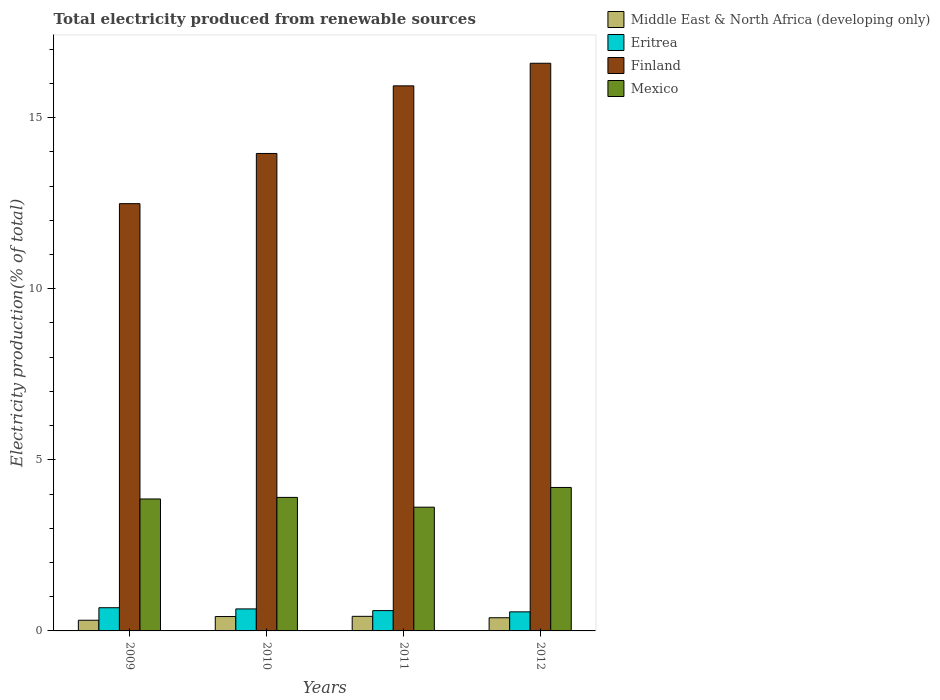Are the number of bars on each tick of the X-axis equal?
Make the answer very short. Yes. What is the total electricity produced in Eritrea in 2009?
Make the answer very short. 0.68. Across all years, what is the maximum total electricity produced in Eritrea?
Offer a very short reply. 0.68. Across all years, what is the minimum total electricity produced in Middle East & North Africa (developing only)?
Offer a terse response. 0.31. In which year was the total electricity produced in Middle East & North Africa (developing only) maximum?
Your answer should be very brief. 2011. In which year was the total electricity produced in Finland minimum?
Ensure brevity in your answer.  2009. What is the total total electricity produced in Eritrea in the graph?
Provide a short and direct response. 2.47. What is the difference between the total electricity produced in Middle East & North Africa (developing only) in 2011 and that in 2012?
Your response must be concise. 0.04. What is the difference between the total electricity produced in Eritrea in 2011 and the total electricity produced in Finland in 2009?
Make the answer very short. -11.89. What is the average total electricity produced in Mexico per year?
Your answer should be compact. 3.89. In the year 2009, what is the difference between the total electricity produced in Eritrea and total electricity produced in Middle East & North Africa (developing only)?
Make the answer very short. 0.37. What is the ratio of the total electricity produced in Mexico in 2011 to that in 2012?
Ensure brevity in your answer.  0.86. What is the difference between the highest and the second highest total electricity produced in Eritrea?
Offer a very short reply. 0.03. What is the difference between the highest and the lowest total electricity produced in Mexico?
Keep it short and to the point. 0.58. In how many years, is the total electricity produced in Eritrea greater than the average total electricity produced in Eritrea taken over all years?
Provide a succinct answer. 2. Is the sum of the total electricity produced in Middle East & North Africa (developing only) in 2010 and 2012 greater than the maximum total electricity produced in Eritrea across all years?
Give a very brief answer. Yes. What does the 1st bar from the left in 2012 represents?
Your answer should be compact. Middle East & North Africa (developing only). Is it the case that in every year, the sum of the total electricity produced in Finland and total electricity produced in Eritrea is greater than the total electricity produced in Mexico?
Make the answer very short. Yes. How many bars are there?
Offer a very short reply. 16. What is the difference between two consecutive major ticks on the Y-axis?
Give a very brief answer. 5. Does the graph contain grids?
Your answer should be very brief. No. Where does the legend appear in the graph?
Ensure brevity in your answer.  Top right. How many legend labels are there?
Give a very brief answer. 4. What is the title of the graph?
Your response must be concise. Total electricity produced from renewable sources. Does "Guinea" appear as one of the legend labels in the graph?
Offer a terse response. No. What is the label or title of the X-axis?
Offer a very short reply. Years. What is the label or title of the Y-axis?
Ensure brevity in your answer.  Electricity production(% of total). What is the Electricity production(% of total) of Middle East & North Africa (developing only) in 2009?
Keep it short and to the point. 0.31. What is the Electricity production(% of total) of Eritrea in 2009?
Give a very brief answer. 0.68. What is the Electricity production(% of total) of Finland in 2009?
Your answer should be compact. 12.49. What is the Electricity production(% of total) in Mexico in 2009?
Your answer should be very brief. 3.86. What is the Electricity production(% of total) of Middle East & North Africa (developing only) in 2010?
Offer a terse response. 0.42. What is the Electricity production(% of total) of Eritrea in 2010?
Keep it short and to the point. 0.64. What is the Electricity production(% of total) of Finland in 2010?
Your response must be concise. 13.95. What is the Electricity production(% of total) of Mexico in 2010?
Provide a succinct answer. 3.9. What is the Electricity production(% of total) of Middle East & North Africa (developing only) in 2011?
Offer a terse response. 0.43. What is the Electricity production(% of total) in Eritrea in 2011?
Give a very brief answer. 0.59. What is the Electricity production(% of total) in Finland in 2011?
Provide a short and direct response. 15.93. What is the Electricity production(% of total) of Mexico in 2011?
Your answer should be compact. 3.62. What is the Electricity production(% of total) of Middle East & North Africa (developing only) in 2012?
Offer a very short reply. 0.38. What is the Electricity production(% of total) of Eritrea in 2012?
Make the answer very short. 0.56. What is the Electricity production(% of total) in Finland in 2012?
Your answer should be very brief. 16.59. What is the Electricity production(% of total) in Mexico in 2012?
Provide a short and direct response. 4.19. Across all years, what is the maximum Electricity production(% of total) in Middle East & North Africa (developing only)?
Offer a terse response. 0.43. Across all years, what is the maximum Electricity production(% of total) in Eritrea?
Give a very brief answer. 0.68. Across all years, what is the maximum Electricity production(% of total) of Finland?
Offer a terse response. 16.59. Across all years, what is the maximum Electricity production(% of total) in Mexico?
Offer a terse response. 4.19. Across all years, what is the minimum Electricity production(% of total) of Middle East & North Africa (developing only)?
Your response must be concise. 0.31. Across all years, what is the minimum Electricity production(% of total) in Eritrea?
Offer a terse response. 0.56. Across all years, what is the minimum Electricity production(% of total) of Finland?
Your answer should be very brief. 12.49. Across all years, what is the minimum Electricity production(% of total) of Mexico?
Provide a short and direct response. 3.62. What is the total Electricity production(% of total) in Middle East & North Africa (developing only) in the graph?
Give a very brief answer. 1.54. What is the total Electricity production(% of total) of Eritrea in the graph?
Your response must be concise. 2.47. What is the total Electricity production(% of total) in Finland in the graph?
Offer a terse response. 58.96. What is the total Electricity production(% of total) of Mexico in the graph?
Ensure brevity in your answer.  15.57. What is the difference between the Electricity production(% of total) of Middle East & North Africa (developing only) in 2009 and that in 2010?
Offer a very short reply. -0.11. What is the difference between the Electricity production(% of total) of Eritrea in 2009 and that in 2010?
Make the answer very short. 0.03. What is the difference between the Electricity production(% of total) of Finland in 2009 and that in 2010?
Your answer should be very brief. -1.47. What is the difference between the Electricity production(% of total) of Mexico in 2009 and that in 2010?
Offer a very short reply. -0.05. What is the difference between the Electricity production(% of total) in Middle East & North Africa (developing only) in 2009 and that in 2011?
Ensure brevity in your answer.  -0.11. What is the difference between the Electricity production(% of total) in Eritrea in 2009 and that in 2011?
Provide a succinct answer. 0.08. What is the difference between the Electricity production(% of total) in Finland in 2009 and that in 2011?
Make the answer very short. -3.44. What is the difference between the Electricity production(% of total) in Mexico in 2009 and that in 2011?
Offer a very short reply. 0.24. What is the difference between the Electricity production(% of total) of Middle East & North Africa (developing only) in 2009 and that in 2012?
Ensure brevity in your answer.  -0.07. What is the difference between the Electricity production(% of total) in Eritrea in 2009 and that in 2012?
Provide a succinct answer. 0.12. What is the difference between the Electricity production(% of total) of Finland in 2009 and that in 2012?
Your answer should be compact. -4.1. What is the difference between the Electricity production(% of total) of Mexico in 2009 and that in 2012?
Provide a succinct answer. -0.34. What is the difference between the Electricity production(% of total) of Middle East & North Africa (developing only) in 2010 and that in 2011?
Offer a very short reply. -0.01. What is the difference between the Electricity production(% of total) in Eritrea in 2010 and that in 2011?
Provide a succinct answer. 0.05. What is the difference between the Electricity production(% of total) of Finland in 2010 and that in 2011?
Give a very brief answer. -1.98. What is the difference between the Electricity production(% of total) of Mexico in 2010 and that in 2011?
Your response must be concise. 0.29. What is the difference between the Electricity production(% of total) in Middle East & North Africa (developing only) in 2010 and that in 2012?
Make the answer very short. 0.04. What is the difference between the Electricity production(% of total) of Eritrea in 2010 and that in 2012?
Keep it short and to the point. 0.09. What is the difference between the Electricity production(% of total) of Finland in 2010 and that in 2012?
Ensure brevity in your answer.  -2.64. What is the difference between the Electricity production(% of total) in Mexico in 2010 and that in 2012?
Provide a succinct answer. -0.29. What is the difference between the Electricity production(% of total) of Middle East & North Africa (developing only) in 2011 and that in 2012?
Your response must be concise. 0.04. What is the difference between the Electricity production(% of total) of Eritrea in 2011 and that in 2012?
Provide a short and direct response. 0.04. What is the difference between the Electricity production(% of total) in Finland in 2011 and that in 2012?
Keep it short and to the point. -0.66. What is the difference between the Electricity production(% of total) in Mexico in 2011 and that in 2012?
Ensure brevity in your answer.  -0.58. What is the difference between the Electricity production(% of total) of Middle East & North Africa (developing only) in 2009 and the Electricity production(% of total) of Eritrea in 2010?
Provide a succinct answer. -0.33. What is the difference between the Electricity production(% of total) of Middle East & North Africa (developing only) in 2009 and the Electricity production(% of total) of Finland in 2010?
Give a very brief answer. -13.64. What is the difference between the Electricity production(% of total) in Middle East & North Africa (developing only) in 2009 and the Electricity production(% of total) in Mexico in 2010?
Provide a short and direct response. -3.59. What is the difference between the Electricity production(% of total) of Eritrea in 2009 and the Electricity production(% of total) of Finland in 2010?
Make the answer very short. -13.28. What is the difference between the Electricity production(% of total) in Eritrea in 2009 and the Electricity production(% of total) in Mexico in 2010?
Make the answer very short. -3.22. What is the difference between the Electricity production(% of total) in Finland in 2009 and the Electricity production(% of total) in Mexico in 2010?
Keep it short and to the point. 8.58. What is the difference between the Electricity production(% of total) of Middle East & North Africa (developing only) in 2009 and the Electricity production(% of total) of Eritrea in 2011?
Offer a terse response. -0.28. What is the difference between the Electricity production(% of total) of Middle East & North Africa (developing only) in 2009 and the Electricity production(% of total) of Finland in 2011?
Your response must be concise. -15.62. What is the difference between the Electricity production(% of total) of Middle East & North Africa (developing only) in 2009 and the Electricity production(% of total) of Mexico in 2011?
Your response must be concise. -3.3. What is the difference between the Electricity production(% of total) in Eritrea in 2009 and the Electricity production(% of total) in Finland in 2011?
Make the answer very short. -15.25. What is the difference between the Electricity production(% of total) of Eritrea in 2009 and the Electricity production(% of total) of Mexico in 2011?
Give a very brief answer. -2.94. What is the difference between the Electricity production(% of total) of Finland in 2009 and the Electricity production(% of total) of Mexico in 2011?
Offer a very short reply. 8.87. What is the difference between the Electricity production(% of total) of Middle East & North Africa (developing only) in 2009 and the Electricity production(% of total) of Eritrea in 2012?
Make the answer very short. -0.24. What is the difference between the Electricity production(% of total) of Middle East & North Africa (developing only) in 2009 and the Electricity production(% of total) of Finland in 2012?
Your response must be concise. -16.28. What is the difference between the Electricity production(% of total) of Middle East & North Africa (developing only) in 2009 and the Electricity production(% of total) of Mexico in 2012?
Your answer should be compact. -3.88. What is the difference between the Electricity production(% of total) of Eritrea in 2009 and the Electricity production(% of total) of Finland in 2012?
Your response must be concise. -15.91. What is the difference between the Electricity production(% of total) of Eritrea in 2009 and the Electricity production(% of total) of Mexico in 2012?
Provide a short and direct response. -3.51. What is the difference between the Electricity production(% of total) of Finland in 2009 and the Electricity production(% of total) of Mexico in 2012?
Provide a short and direct response. 8.29. What is the difference between the Electricity production(% of total) of Middle East & North Africa (developing only) in 2010 and the Electricity production(% of total) of Eritrea in 2011?
Give a very brief answer. -0.17. What is the difference between the Electricity production(% of total) of Middle East & North Africa (developing only) in 2010 and the Electricity production(% of total) of Finland in 2011?
Your answer should be very brief. -15.51. What is the difference between the Electricity production(% of total) of Middle East & North Africa (developing only) in 2010 and the Electricity production(% of total) of Mexico in 2011?
Your response must be concise. -3.2. What is the difference between the Electricity production(% of total) in Eritrea in 2010 and the Electricity production(% of total) in Finland in 2011?
Offer a terse response. -15.29. What is the difference between the Electricity production(% of total) of Eritrea in 2010 and the Electricity production(% of total) of Mexico in 2011?
Your answer should be compact. -2.97. What is the difference between the Electricity production(% of total) of Finland in 2010 and the Electricity production(% of total) of Mexico in 2011?
Your answer should be very brief. 10.34. What is the difference between the Electricity production(% of total) of Middle East & North Africa (developing only) in 2010 and the Electricity production(% of total) of Eritrea in 2012?
Provide a short and direct response. -0.14. What is the difference between the Electricity production(% of total) of Middle East & North Africa (developing only) in 2010 and the Electricity production(% of total) of Finland in 2012?
Make the answer very short. -16.17. What is the difference between the Electricity production(% of total) of Middle East & North Africa (developing only) in 2010 and the Electricity production(% of total) of Mexico in 2012?
Offer a terse response. -3.77. What is the difference between the Electricity production(% of total) of Eritrea in 2010 and the Electricity production(% of total) of Finland in 2012?
Offer a very short reply. -15.95. What is the difference between the Electricity production(% of total) in Eritrea in 2010 and the Electricity production(% of total) in Mexico in 2012?
Your answer should be compact. -3.55. What is the difference between the Electricity production(% of total) of Finland in 2010 and the Electricity production(% of total) of Mexico in 2012?
Offer a terse response. 9.76. What is the difference between the Electricity production(% of total) of Middle East & North Africa (developing only) in 2011 and the Electricity production(% of total) of Eritrea in 2012?
Give a very brief answer. -0.13. What is the difference between the Electricity production(% of total) in Middle East & North Africa (developing only) in 2011 and the Electricity production(% of total) in Finland in 2012?
Your answer should be compact. -16.16. What is the difference between the Electricity production(% of total) of Middle East & North Africa (developing only) in 2011 and the Electricity production(% of total) of Mexico in 2012?
Make the answer very short. -3.77. What is the difference between the Electricity production(% of total) of Eritrea in 2011 and the Electricity production(% of total) of Finland in 2012?
Offer a terse response. -16. What is the difference between the Electricity production(% of total) of Eritrea in 2011 and the Electricity production(% of total) of Mexico in 2012?
Make the answer very short. -3.6. What is the difference between the Electricity production(% of total) in Finland in 2011 and the Electricity production(% of total) in Mexico in 2012?
Offer a terse response. 11.74. What is the average Electricity production(% of total) in Middle East & North Africa (developing only) per year?
Keep it short and to the point. 0.39. What is the average Electricity production(% of total) of Eritrea per year?
Keep it short and to the point. 0.62. What is the average Electricity production(% of total) of Finland per year?
Your answer should be very brief. 14.74. What is the average Electricity production(% of total) in Mexico per year?
Ensure brevity in your answer.  3.89. In the year 2009, what is the difference between the Electricity production(% of total) of Middle East & North Africa (developing only) and Electricity production(% of total) of Eritrea?
Your answer should be very brief. -0.37. In the year 2009, what is the difference between the Electricity production(% of total) of Middle East & North Africa (developing only) and Electricity production(% of total) of Finland?
Give a very brief answer. -12.17. In the year 2009, what is the difference between the Electricity production(% of total) in Middle East & North Africa (developing only) and Electricity production(% of total) in Mexico?
Provide a succinct answer. -3.54. In the year 2009, what is the difference between the Electricity production(% of total) in Eritrea and Electricity production(% of total) in Finland?
Your answer should be very brief. -11.81. In the year 2009, what is the difference between the Electricity production(% of total) of Eritrea and Electricity production(% of total) of Mexico?
Keep it short and to the point. -3.18. In the year 2009, what is the difference between the Electricity production(% of total) in Finland and Electricity production(% of total) in Mexico?
Ensure brevity in your answer.  8.63. In the year 2010, what is the difference between the Electricity production(% of total) of Middle East & North Africa (developing only) and Electricity production(% of total) of Eritrea?
Provide a short and direct response. -0.22. In the year 2010, what is the difference between the Electricity production(% of total) of Middle East & North Africa (developing only) and Electricity production(% of total) of Finland?
Ensure brevity in your answer.  -13.53. In the year 2010, what is the difference between the Electricity production(% of total) in Middle East & North Africa (developing only) and Electricity production(% of total) in Mexico?
Your answer should be compact. -3.48. In the year 2010, what is the difference between the Electricity production(% of total) of Eritrea and Electricity production(% of total) of Finland?
Your answer should be compact. -13.31. In the year 2010, what is the difference between the Electricity production(% of total) in Eritrea and Electricity production(% of total) in Mexico?
Your response must be concise. -3.26. In the year 2010, what is the difference between the Electricity production(% of total) in Finland and Electricity production(% of total) in Mexico?
Make the answer very short. 10.05. In the year 2011, what is the difference between the Electricity production(% of total) of Middle East & North Africa (developing only) and Electricity production(% of total) of Eritrea?
Provide a short and direct response. -0.17. In the year 2011, what is the difference between the Electricity production(% of total) of Middle East & North Africa (developing only) and Electricity production(% of total) of Finland?
Provide a short and direct response. -15.5. In the year 2011, what is the difference between the Electricity production(% of total) of Middle East & North Africa (developing only) and Electricity production(% of total) of Mexico?
Make the answer very short. -3.19. In the year 2011, what is the difference between the Electricity production(% of total) in Eritrea and Electricity production(% of total) in Finland?
Keep it short and to the point. -15.34. In the year 2011, what is the difference between the Electricity production(% of total) of Eritrea and Electricity production(% of total) of Mexico?
Offer a terse response. -3.02. In the year 2011, what is the difference between the Electricity production(% of total) of Finland and Electricity production(% of total) of Mexico?
Make the answer very short. 12.31. In the year 2012, what is the difference between the Electricity production(% of total) in Middle East & North Africa (developing only) and Electricity production(% of total) in Eritrea?
Ensure brevity in your answer.  -0.17. In the year 2012, what is the difference between the Electricity production(% of total) in Middle East & North Africa (developing only) and Electricity production(% of total) in Finland?
Provide a succinct answer. -16.2. In the year 2012, what is the difference between the Electricity production(% of total) in Middle East & North Africa (developing only) and Electricity production(% of total) in Mexico?
Your answer should be compact. -3.81. In the year 2012, what is the difference between the Electricity production(% of total) of Eritrea and Electricity production(% of total) of Finland?
Offer a terse response. -16.03. In the year 2012, what is the difference between the Electricity production(% of total) of Eritrea and Electricity production(% of total) of Mexico?
Your response must be concise. -3.64. In the year 2012, what is the difference between the Electricity production(% of total) of Finland and Electricity production(% of total) of Mexico?
Give a very brief answer. 12.4. What is the ratio of the Electricity production(% of total) in Middle East & North Africa (developing only) in 2009 to that in 2010?
Ensure brevity in your answer.  0.74. What is the ratio of the Electricity production(% of total) of Eritrea in 2009 to that in 2010?
Offer a very short reply. 1.05. What is the ratio of the Electricity production(% of total) in Finland in 2009 to that in 2010?
Your answer should be very brief. 0.89. What is the ratio of the Electricity production(% of total) in Middle East & North Africa (developing only) in 2009 to that in 2011?
Provide a short and direct response. 0.73. What is the ratio of the Electricity production(% of total) in Eritrea in 2009 to that in 2011?
Offer a terse response. 1.14. What is the ratio of the Electricity production(% of total) in Finland in 2009 to that in 2011?
Your response must be concise. 0.78. What is the ratio of the Electricity production(% of total) in Mexico in 2009 to that in 2011?
Provide a short and direct response. 1.07. What is the ratio of the Electricity production(% of total) in Middle East & North Africa (developing only) in 2009 to that in 2012?
Keep it short and to the point. 0.81. What is the ratio of the Electricity production(% of total) of Eritrea in 2009 to that in 2012?
Provide a succinct answer. 1.22. What is the ratio of the Electricity production(% of total) in Finland in 2009 to that in 2012?
Your answer should be compact. 0.75. What is the ratio of the Electricity production(% of total) of Mexico in 2009 to that in 2012?
Keep it short and to the point. 0.92. What is the ratio of the Electricity production(% of total) in Eritrea in 2010 to that in 2011?
Your response must be concise. 1.08. What is the ratio of the Electricity production(% of total) of Finland in 2010 to that in 2011?
Make the answer very short. 0.88. What is the ratio of the Electricity production(% of total) of Mexico in 2010 to that in 2011?
Your answer should be very brief. 1.08. What is the ratio of the Electricity production(% of total) of Middle East & North Africa (developing only) in 2010 to that in 2012?
Provide a short and direct response. 1.09. What is the ratio of the Electricity production(% of total) in Eritrea in 2010 to that in 2012?
Offer a terse response. 1.15. What is the ratio of the Electricity production(% of total) of Finland in 2010 to that in 2012?
Offer a terse response. 0.84. What is the ratio of the Electricity production(% of total) in Mexico in 2010 to that in 2012?
Ensure brevity in your answer.  0.93. What is the ratio of the Electricity production(% of total) in Middle East & North Africa (developing only) in 2011 to that in 2012?
Keep it short and to the point. 1.11. What is the ratio of the Electricity production(% of total) of Eritrea in 2011 to that in 2012?
Provide a short and direct response. 1.07. What is the ratio of the Electricity production(% of total) of Finland in 2011 to that in 2012?
Make the answer very short. 0.96. What is the ratio of the Electricity production(% of total) in Mexico in 2011 to that in 2012?
Give a very brief answer. 0.86. What is the difference between the highest and the second highest Electricity production(% of total) of Middle East & North Africa (developing only)?
Your answer should be compact. 0.01. What is the difference between the highest and the second highest Electricity production(% of total) in Eritrea?
Your answer should be compact. 0.03. What is the difference between the highest and the second highest Electricity production(% of total) in Finland?
Your response must be concise. 0.66. What is the difference between the highest and the second highest Electricity production(% of total) in Mexico?
Offer a very short reply. 0.29. What is the difference between the highest and the lowest Electricity production(% of total) in Middle East & North Africa (developing only)?
Your answer should be very brief. 0.11. What is the difference between the highest and the lowest Electricity production(% of total) in Eritrea?
Make the answer very short. 0.12. What is the difference between the highest and the lowest Electricity production(% of total) in Finland?
Give a very brief answer. 4.1. What is the difference between the highest and the lowest Electricity production(% of total) in Mexico?
Your answer should be very brief. 0.58. 